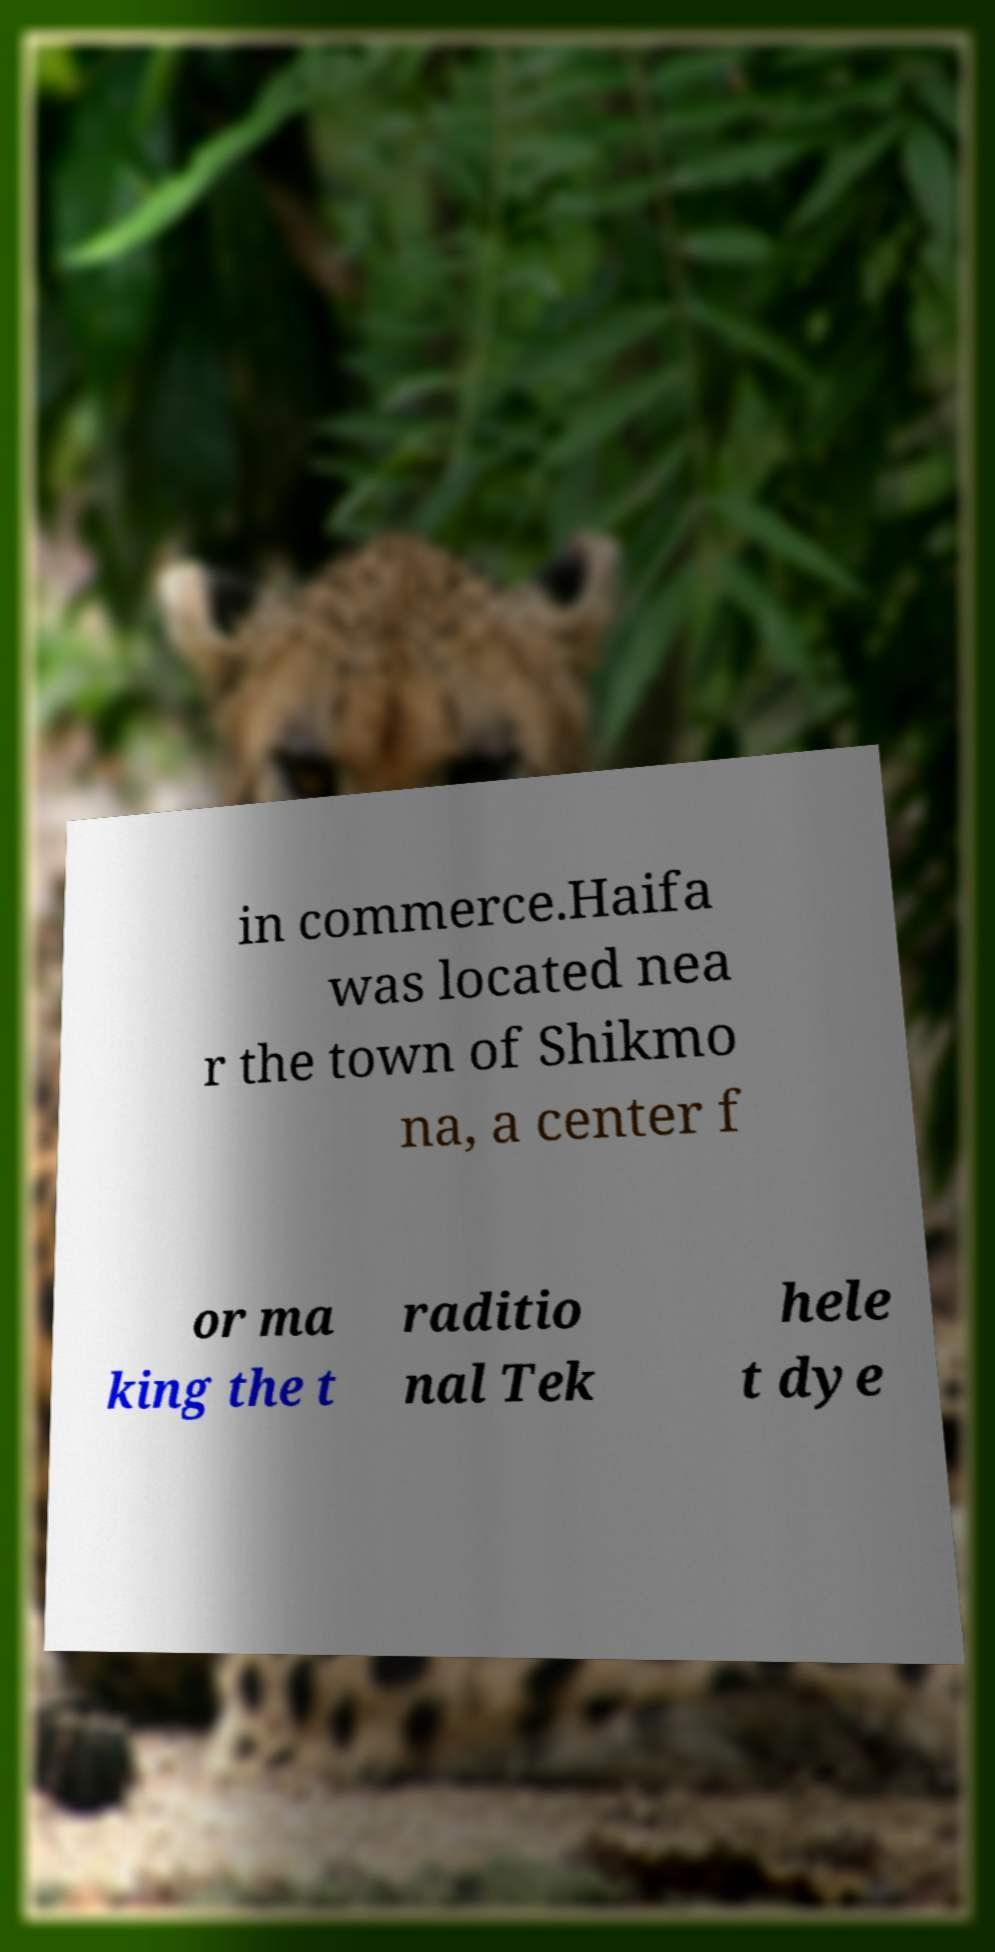What messages or text are displayed in this image? I need them in a readable, typed format. in commerce.Haifa was located nea r the town of Shikmo na, a center f or ma king the t raditio nal Tek hele t dye 